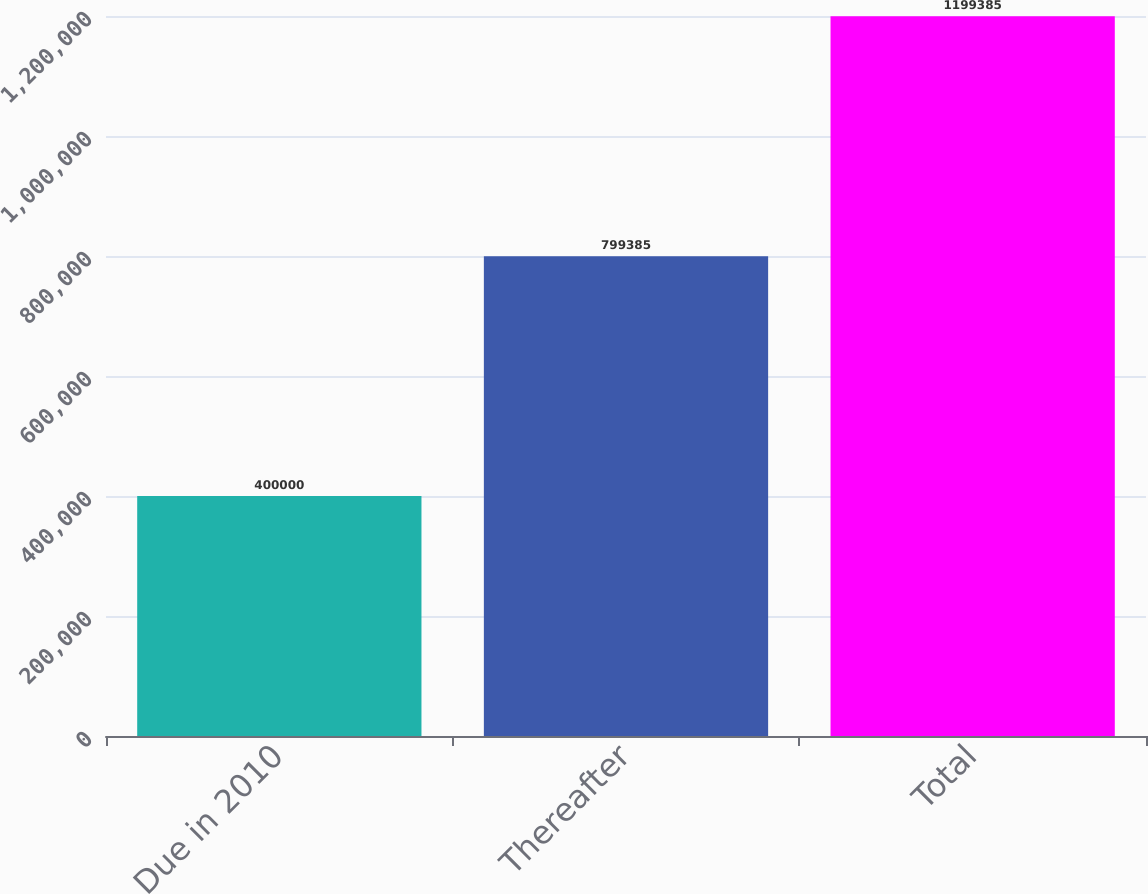Convert chart. <chart><loc_0><loc_0><loc_500><loc_500><bar_chart><fcel>Due in 2010<fcel>Thereafter<fcel>Total<nl><fcel>400000<fcel>799385<fcel>1.19938e+06<nl></chart> 